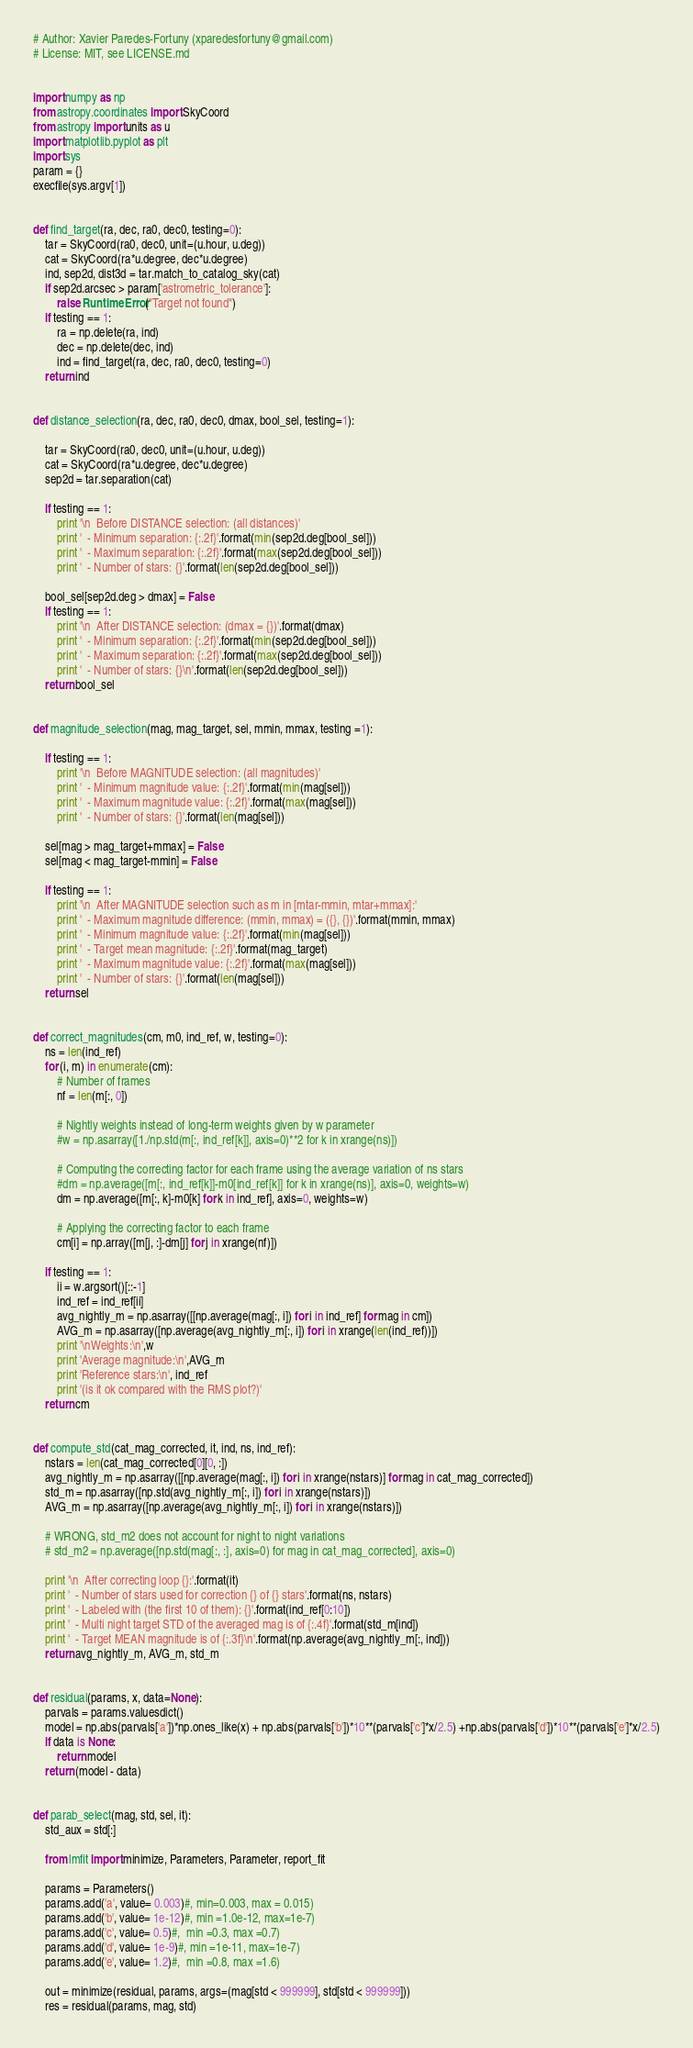Convert code to text. <code><loc_0><loc_0><loc_500><loc_500><_Python_># Author: Xavier Paredes-Fortuny (xparedesfortuny@gmail.com)
# License: MIT, see LICENSE.md


import numpy as np
from astropy.coordinates import SkyCoord
from astropy import units as u
import matplotlib.pyplot as plt
import sys
param = {}
execfile(sys.argv[1])


def find_target(ra, dec, ra0, dec0, testing=0):
    tar = SkyCoord(ra0, dec0, unit=(u.hour, u.deg))
    cat = SkyCoord(ra*u.degree, dec*u.degree)
    ind, sep2d, dist3d = tar.match_to_catalog_sky(cat)
    if sep2d.arcsec > param['astrometric_tolerance']:
        raise RuntimeError("Target not found")
    if testing == 1:
        ra = np.delete(ra, ind)
        dec = np.delete(dec, ind)
        ind = find_target(ra, dec, ra0, dec0, testing=0)
    return ind


def distance_selection(ra, dec, ra0, dec0, dmax, bool_sel, testing=1):

    tar = SkyCoord(ra0, dec0, unit=(u.hour, u.deg))
    cat = SkyCoord(ra*u.degree, dec*u.degree)
    sep2d = tar.separation(cat)

    if testing == 1:
        print '\n  Before DISTANCE selection: (all distances)'
        print '  - Minimum separation: {:.2f}'.format(min(sep2d.deg[bool_sel]))
        print '  - Maximum separation: {:.2f}'.format(max(sep2d.deg[bool_sel]))
        print '  - Number of stars: {}'.format(len(sep2d.deg[bool_sel]))

    bool_sel[sep2d.deg > dmax] = False
    if testing == 1:
        print '\n  After DISTANCE selection: (dmax = {})'.format(dmax)
        print '  - Minimum separation: {:.2f}'.format(min(sep2d.deg[bool_sel]))
        print '  - Maximum separation: {:.2f}'.format(max(sep2d.deg[bool_sel]))
        print '  - Number of stars: {}\n'.format(len(sep2d.deg[bool_sel]))
    return bool_sel


def magnitude_selection(mag, mag_target, sel, mmin, mmax, testing =1):

    if testing == 1:
        print '\n  Before MAGNITUDE selection: (all magnitudes)'
        print '  - Minimum magnitude value: {:.2f}'.format(min(mag[sel]))
        print '  - Maximum magnitude value: {:.2f}'.format(max(mag[sel]))
        print '  - Number of stars: {}'.format(len(mag[sel]))

    sel[mag > mag_target+mmax] = False
    sel[mag < mag_target-mmin] = False

    if testing == 1:
        print '\n  After MAGNITUDE selection such as m in [mtar-mmin, mtar+mmax]:'
        print '  - Maximum magnitude difference: (mmin, mmax) = ({}, {})'.format(mmin, mmax)
        print '  - Minimum magnitude value: {:.2f}'.format(min(mag[sel]))
        print '  - Target mean magnitude: {:.2f}'.format(mag_target)
        print '  - Maximum magnitude value: {:.2f}'.format(max(mag[sel]))
        print '  - Number of stars: {}'.format(len(mag[sel]))
    return sel


def correct_magnitudes(cm, m0, ind_ref, w, testing=0):
    ns = len(ind_ref)
    for (i, m) in enumerate(cm):
        # Number of frames
        nf = len(m[:, 0])

        # Nightly weights instead of long-term weights given by w parameter
        #w = np.asarray([1./np.std(m[:, ind_ref[k]], axis=0)**2 for k in xrange(ns)])

        # Computing the correcting factor for each frame using the average variation of ns stars
        #dm = np.average([m[:, ind_ref[k]]-m0[ind_ref[k]] for k in xrange(ns)], axis=0, weights=w)
        dm = np.average([m[:, k]-m0[k] for k in ind_ref], axis=0, weights=w)

        # Applying the correcting factor to each frame
        cm[i] = np.array([m[j, :]-dm[j] for j in xrange(nf)])

    if testing == 1:
        ii = w.argsort()[::-1]
        ind_ref = ind_ref[ii]
        avg_nightly_m = np.asarray([[np.average(mag[:, i]) for i in ind_ref] for mag in cm])
        AVG_m = np.asarray([np.average(avg_nightly_m[:, i]) for i in xrange(len(ind_ref))])
        print '\nWeights:\n',w
        print 'Average magnitude:\n',AVG_m
        print 'Reference stars:\n', ind_ref
        print '(is it ok compared with the RMS plot?)'
    return cm


def compute_std(cat_mag_corrected, it, ind, ns, ind_ref):
    nstars = len(cat_mag_corrected[0][0, :])
    avg_nightly_m = np.asarray([[np.average(mag[:, i]) for i in xrange(nstars)] for mag in cat_mag_corrected])
    std_m = np.asarray([np.std(avg_nightly_m[:, i]) for i in xrange(nstars)])
    AVG_m = np.asarray([np.average(avg_nightly_m[:, i]) for i in xrange(nstars)])

    # WRONG, std_m2 does not account for night to night variations
    # std_m2 = np.average([np.std(mag[:, :], axis=0) for mag in cat_mag_corrected], axis=0)

    print '\n  After correcting loop {}:'.format(it)
    print '  - Number of stars used for correction {} of {} stars'.format(ns, nstars)
    print '  - Labeled with (the first 10 of them): {}'.format(ind_ref[0:10])
    print '  - Multi night target STD of the averaged mag is of {:.4f}'.format(std_m[ind])
    print '  - Target MEAN magnitude is of {:.3f}\n'.format(np.average(avg_nightly_m[:, ind]))
    return avg_nightly_m, AVG_m, std_m


def residual(params, x, data=None):
    parvals = params.valuesdict()
    model = np.abs(parvals['a'])*np.ones_like(x) + np.abs(parvals['b'])*10**(parvals['c']*x/2.5) +np.abs(parvals['d'])*10**(parvals['e']*x/2.5)
    if data is None:
        return model
    return (model - data)


def parab_select(mag, std, sel, it):
    std_aux = std[:]

    from lmfit import minimize, Parameters, Parameter, report_fit

    params = Parameters()
    params.add('a', value= 0.003)#, min=0.003, max = 0.015)
    params.add('b', value= 1e-12)#, min =1.0e-12, max=1e-7)
    params.add('c', value= 0.5)#,  min =0.3, max =0.7)
    params.add('d', value= 1e-9)#, min =1e-11, max=1e-7)
    params.add('e', value= 1.2)#,  min =0.8, max =1.6)

    out = minimize(residual, params, args=(mag[std < 999999], std[std < 999999]))
    res = residual(params, mag, std)</code> 